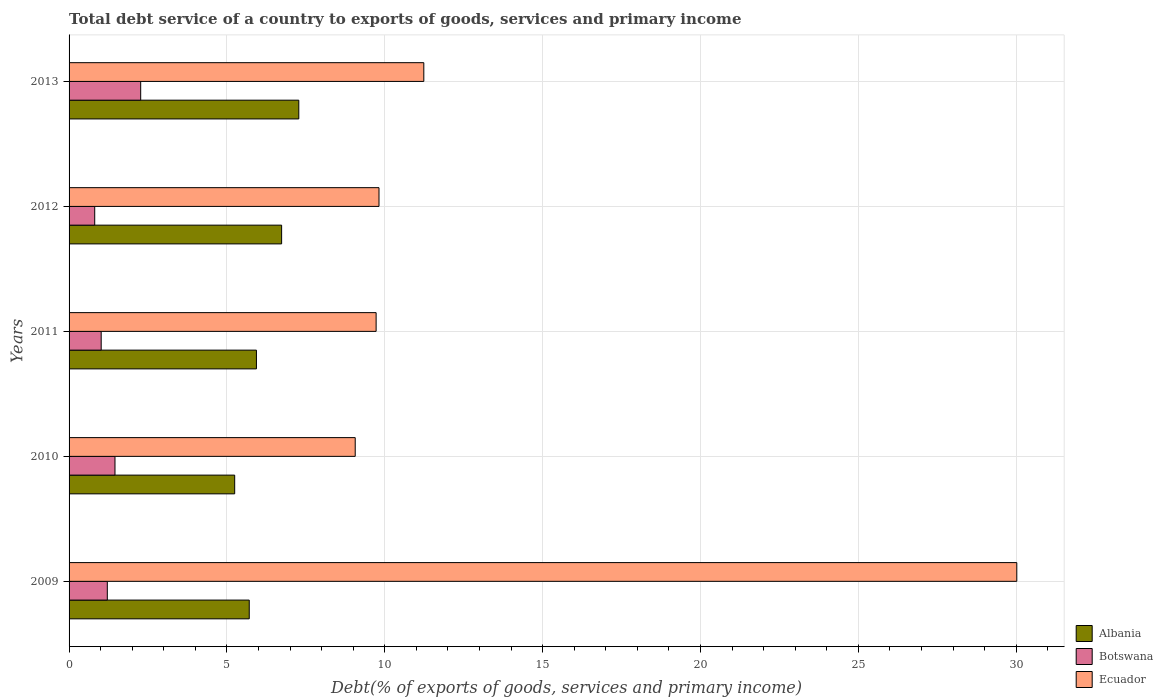How many different coloured bars are there?
Give a very brief answer. 3. How many groups of bars are there?
Your answer should be very brief. 5. How many bars are there on the 3rd tick from the bottom?
Your answer should be very brief. 3. What is the label of the 2nd group of bars from the top?
Your answer should be very brief. 2012. In how many cases, is the number of bars for a given year not equal to the number of legend labels?
Your response must be concise. 0. What is the total debt service in Albania in 2010?
Your answer should be compact. 5.25. Across all years, what is the maximum total debt service in Albania?
Offer a very short reply. 7.28. Across all years, what is the minimum total debt service in Botswana?
Your response must be concise. 0.81. In which year was the total debt service in Albania minimum?
Provide a short and direct response. 2010. What is the total total debt service in Ecuador in the graph?
Your answer should be very brief. 69.87. What is the difference between the total debt service in Botswana in 2012 and that in 2013?
Offer a very short reply. -1.46. What is the difference between the total debt service in Botswana in 2011 and the total debt service in Ecuador in 2012?
Offer a very short reply. -8.8. What is the average total debt service in Botswana per year?
Make the answer very short. 1.35. In the year 2010, what is the difference between the total debt service in Albania and total debt service in Ecuador?
Your answer should be very brief. -3.82. In how many years, is the total debt service in Ecuador greater than 13 %?
Offer a terse response. 1. What is the ratio of the total debt service in Botswana in 2011 to that in 2012?
Ensure brevity in your answer.  1.25. What is the difference between the highest and the second highest total debt service in Ecuador?
Offer a very short reply. 18.78. What is the difference between the highest and the lowest total debt service in Botswana?
Offer a very short reply. 1.46. Is the sum of the total debt service in Botswana in 2009 and 2010 greater than the maximum total debt service in Ecuador across all years?
Keep it short and to the point. No. What does the 3rd bar from the top in 2009 represents?
Offer a terse response. Albania. What does the 2nd bar from the bottom in 2009 represents?
Provide a short and direct response. Botswana. How many bars are there?
Give a very brief answer. 15. How many years are there in the graph?
Provide a short and direct response. 5. What is the difference between two consecutive major ticks on the X-axis?
Your answer should be compact. 5. Does the graph contain grids?
Offer a very short reply. Yes. What is the title of the graph?
Give a very brief answer. Total debt service of a country to exports of goods, services and primary income. Does "Iran" appear as one of the legend labels in the graph?
Offer a terse response. No. What is the label or title of the X-axis?
Make the answer very short. Debt(% of exports of goods, services and primary income). What is the label or title of the Y-axis?
Your answer should be very brief. Years. What is the Debt(% of exports of goods, services and primary income) of Albania in 2009?
Keep it short and to the point. 5.71. What is the Debt(% of exports of goods, services and primary income) in Botswana in 2009?
Provide a short and direct response. 1.21. What is the Debt(% of exports of goods, services and primary income) of Ecuador in 2009?
Keep it short and to the point. 30.02. What is the Debt(% of exports of goods, services and primary income) of Albania in 2010?
Your response must be concise. 5.25. What is the Debt(% of exports of goods, services and primary income) in Botswana in 2010?
Make the answer very short. 1.45. What is the Debt(% of exports of goods, services and primary income) in Ecuador in 2010?
Offer a very short reply. 9.06. What is the Debt(% of exports of goods, services and primary income) of Albania in 2011?
Ensure brevity in your answer.  5.94. What is the Debt(% of exports of goods, services and primary income) in Botswana in 2011?
Your response must be concise. 1.02. What is the Debt(% of exports of goods, services and primary income) of Ecuador in 2011?
Your response must be concise. 9.73. What is the Debt(% of exports of goods, services and primary income) in Albania in 2012?
Offer a very short reply. 6.73. What is the Debt(% of exports of goods, services and primary income) in Botswana in 2012?
Make the answer very short. 0.81. What is the Debt(% of exports of goods, services and primary income) of Ecuador in 2012?
Provide a succinct answer. 9.82. What is the Debt(% of exports of goods, services and primary income) in Albania in 2013?
Offer a terse response. 7.28. What is the Debt(% of exports of goods, services and primary income) of Botswana in 2013?
Your response must be concise. 2.27. What is the Debt(% of exports of goods, services and primary income) in Ecuador in 2013?
Make the answer very short. 11.24. Across all years, what is the maximum Debt(% of exports of goods, services and primary income) of Albania?
Make the answer very short. 7.28. Across all years, what is the maximum Debt(% of exports of goods, services and primary income) of Botswana?
Your answer should be very brief. 2.27. Across all years, what is the maximum Debt(% of exports of goods, services and primary income) in Ecuador?
Provide a short and direct response. 30.02. Across all years, what is the minimum Debt(% of exports of goods, services and primary income) in Albania?
Make the answer very short. 5.25. Across all years, what is the minimum Debt(% of exports of goods, services and primary income) in Botswana?
Provide a succinct answer. 0.81. Across all years, what is the minimum Debt(% of exports of goods, services and primary income) in Ecuador?
Ensure brevity in your answer.  9.06. What is the total Debt(% of exports of goods, services and primary income) of Albania in the graph?
Offer a very short reply. 30.9. What is the total Debt(% of exports of goods, services and primary income) in Botswana in the graph?
Your answer should be compact. 6.76. What is the total Debt(% of exports of goods, services and primary income) in Ecuador in the graph?
Make the answer very short. 69.87. What is the difference between the Debt(% of exports of goods, services and primary income) in Albania in 2009 and that in 2010?
Your answer should be compact. 0.46. What is the difference between the Debt(% of exports of goods, services and primary income) in Botswana in 2009 and that in 2010?
Keep it short and to the point. -0.24. What is the difference between the Debt(% of exports of goods, services and primary income) of Ecuador in 2009 and that in 2010?
Keep it short and to the point. 20.96. What is the difference between the Debt(% of exports of goods, services and primary income) of Albania in 2009 and that in 2011?
Provide a succinct answer. -0.23. What is the difference between the Debt(% of exports of goods, services and primary income) of Botswana in 2009 and that in 2011?
Your answer should be very brief. 0.19. What is the difference between the Debt(% of exports of goods, services and primary income) in Ecuador in 2009 and that in 2011?
Provide a succinct answer. 20.29. What is the difference between the Debt(% of exports of goods, services and primary income) in Albania in 2009 and that in 2012?
Make the answer very short. -1.03. What is the difference between the Debt(% of exports of goods, services and primary income) of Botswana in 2009 and that in 2012?
Ensure brevity in your answer.  0.4. What is the difference between the Debt(% of exports of goods, services and primary income) in Ecuador in 2009 and that in 2012?
Offer a terse response. 20.2. What is the difference between the Debt(% of exports of goods, services and primary income) in Albania in 2009 and that in 2013?
Offer a very short reply. -1.57. What is the difference between the Debt(% of exports of goods, services and primary income) of Botswana in 2009 and that in 2013?
Offer a very short reply. -1.06. What is the difference between the Debt(% of exports of goods, services and primary income) in Ecuador in 2009 and that in 2013?
Your answer should be compact. 18.78. What is the difference between the Debt(% of exports of goods, services and primary income) of Albania in 2010 and that in 2011?
Your answer should be very brief. -0.69. What is the difference between the Debt(% of exports of goods, services and primary income) in Botswana in 2010 and that in 2011?
Provide a short and direct response. 0.44. What is the difference between the Debt(% of exports of goods, services and primary income) in Ecuador in 2010 and that in 2011?
Your answer should be very brief. -0.66. What is the difference between the Debt(% of exports of goods, services and primary income) in Albania in 2010 and that in 2012?
Keep it short and to the point. -1.49. What is the difference between the Debt(% of exports of goods, services and primary income) in Botswana in 2010 and that in 2012?
Make the answer very short. 0.64. What is the difference between the Debt(% of exports of goods, services and primary income) in Ecuador in 2010 and that in 2012?
Keep it short and to the point. -0.75. What is the difference between the Debt(% of exports of goods, services and primary income) of Albania in 2010 and that in 2013?
Provide a short and direct response. -2.03. What is the difference between the Debt(% of exports of goods, services and primary income) in Botswana in 2010 and that in 2013?
Offer a terse response. -0.81. What is the difference between the Debt(% of exports of goods, services and primary income) of Ecuador in 2010 and that in 2013?
Your response must be concise. -2.17. What is the difference between the Debt(% of exports of goods, services and primary income) of Albania in 2011 and that in 2012?
Offer a terse response. -0.8. What is the difference between the Debt(% of exports of goods, services and primary income) in Botswana in 2011 and that in 2012?
Offer a very short reply. 0.2. What is the difference between the Debt(% of exports of goods, services and primary income) in Ecuador in 2011 and that in 2012?
Give a very brief answer. -0.09. What is the difference between the Debt(% of exports of goods, services and primary income) in Albania in 2011 and that in 2013?
Offer a very short reply. -1.34. What is the difference between the Debt(% of exports of goods, services and primary income) in Botswana in 2011 and that in 2013?
Offer a terse response. -1.25. What is the difference between the Debt(% of exports of goods, services and primary income) of Ecuador in 2011 and that in 2013?
Offer a very short reply. -1.51. What is the difference between the Debt(% of exports of goods, services and primary income) in Albania in 2012 and that in 2013?
Your response must be concise. -0.54. What is the difference between the Debt(% of exports of goods, services and primary income) of Botswana in 2012 and that in 2013?
Provide a succinct answer. -1.46. What is the difference between the Debt(% of exports of goods, services and primary income) of Ecuador in 2012 and that in 2013?
Offer a terse response. -1.42. What is the difference between the Debt(% of exports of goods, services and primary income) of Albania in 2009 and the Debt(% of exports of goods, services and primary income) of Botswana in 2010?
Your answer should be very brief. 4.25. What is the difference between the Debt(% of exports of goods, services and primary income) in Albania in 2009 and the Debt(% of exports of goods, services and primary income) in Ecuador in 2010?
Your answer should be very brief. -3.36. What is the difference between the Debt(% of exports of goods, services and primary income) in Botswana in 2009 and the Debt(% of exports of goods, services and primary income) in Ecuador in 2010?
Provide a succinct answer. -7.85. What is the difference between the Debt(% of exports of goods, services and primary income) of Albania in 2009 and the Debt(% of exports of goods, services and primary income) of Botswana in 2011?
Your response must be concise. 4.69. What is the difference between the Debt(% of exports of goods, services and primary income) of Albania in 2009 and the Debt(% of exports of goods, services and primary income) of Ecuador in 2011?
Provide a succinct answer. -4.02. What is the difference between the Debt(% of exports of goods, services and primary income) in Botswana in 2009 and the Debt(% of exports of goods, services and primary income) in Ecuador in 2011?
Make the answer very short. -8.52. What is the difference between the Debt(% of exports of goods, services and primary income) of Albania in 2009 and the Debt(% of exports of goods, services and primary income) of Botswana in 2012?
Offer a very short reply. 4.89. What is the difference between the Debt(% of exports of goods, services and primary income) in Albania in 2009 and the Debt(% of exports of goods, services and primary income) in Ecuador in 2012?
Offer a very short reply. -4.11. What is the difference between the Debt(% of exports of goods, services and primary income) in Botswana in 2009 and the Debt(% of exports of goods, services and primary income) in Ecuador in 2012?
Provide a succinct answer. -8.61. What is the difference between the Debt(% of exports of goods, services and primary income) in Albania in 2009 and the Debt(% of exports of goods, services and primary income) in Botswana in 2013?
Offer a very short reply. 3.44. What is the difference between the Debt(% of exports of goods, services and primary income) of Albania in 2009 and the Debt(% of exports of goods, services and primary income) of Ecuador in 2013?
Your answer should be very brief. -5.53. What is the difference between the Debt(% of exports of goods, services and primary income) in Botswana in 2009 and the Debt(% of exports of goods, services and primary income) in Ecuador in 2013?
Make the answer very short. -10.03. What is the difference between the Debt(% of exports of goods, services and primary income) of Albania in 2010 and the Debt(% of exports of goods, services and primary income) of Botswana in 2011?
Give a very brief answer. 4.23. What is the difference between the Debt(% of exports of goods, services and primary income) in Albania in 2010 and the Debt(% of exports of goods, services and primary income) in Ecuador in 2011?
Give a very brief answer. -4.48. What is the difference between the Debt(% of exports of goods, services and primary income) in Botswana in 2010 and the Debt(% of exports of goods, services and primary income) in Ecuador in 2011?
Keep it short and to the point. -8.27. What is the difference between the Debt(% of exports of goods, services and primary income) in Albania in 2010 and the Debt(% of exports of goods, services and primary income) in Botswana in 2012?
Provide a succinct answer. 4.43. What is the difference between the Debt(% of exports of goods, services and primary income) in Albania in 2010 and the Debt(% of exports of goods, services and primary income) in Ecuador in 2012?
Keep it short and to the point. -4.57. What is the difference between the Debt(% of exports of goods, services and primary income) of Botswana in 2010 and the Debt(% of exports of goods, services and primary income) of Ecuador in 2012?
Your answer should be compact. -8.36. What is the difference between the Debt(% of exports of goods, services and primary income) in Albania in 2010 and the Debt(% of exports of goods, services and primary income) in Botswana in 2013?
Your answer should be very brief. 2.98. What is the difference between the Debt(% of exports of goods, services and primary income) of Albania in 2010 and the Debt(% of exports of goods, services and primary income) of Ecuador in 2013?
Offer a terse response. -5.99. What is the difference between the Debt(% of exports of goods, services and primary income) in Botswana in 2010 and the Debt(% of exports of goods, services and primary income) in Ecuador in 2013?
Your answer should be compact. -9.78. What is the difference between the Debt(% of exports of goods, services and primary income) in Albania in 2011 and the Debt(% of exports of goods, services and primary income) in Botswana in 2012?
Ensure brevity in your answer.  5.12. What is the difference between the Debt(% of exports of goods, services and primary income) of Albania in 2011 and the Debt(% of exports of goods, services and primary income) of Ecuador in 2012?
Offer a very short reply. -3.88. What is the difference between the Debt(% of exports of goods, services and primary income) of Botswana in 2011 and the Debt(% of exports of goods, services and primary income) of Ecuador in 2012?
Offer a terse response. -8.8. What is the difference between the Debt(% of exports of goods, services and primary income) of Albania in 2011 and the Debt(% of exports of goods, services and primary income) of Botswana in 2013?
Provide a succinct answer. 3.67. What is the difference between the Debt(% of exports of goods, services and primary income) of Albania in 2011 and the Debt(% of exports of goods, services and primary income) of Ecuador in 2013?
Offer a very short reply. -5.3. What is the difference between the Debt(% of exports of goods, services and primary income) of Botswana in 2011 and the Debt(% of exports of goods, services and primary income) of Ecuador in 2013?
Provide a succinct answer. -10.22. What is the difference between the Debt(% of exports of goods, services and primary income) in Albania in 2012 and the Debt(% of exports of goods, services and primary income) in Botswana in 2013?
Provide a short and direct response. 4.46. What is the difference between the Debt(% of exports of goods, services and primary income) of Albania in 2012 and the Debt(% of exports of goods, services and primary income) of Ecuador in 2013?
Ensure brevity in your answer.  -4.5. What is the difference between the Debt(% of exports of goods, services and primary income) of Botswana in 2012 and the Debt(% of exports of goods, services and primary income) of Ecuador in 2013?
Provide a short and direct response. -10.42. What is the average Debt(% of exports of goods, services and primary income) in Albania per year?
Provide a short and direct response. 6.18. What is the average Debt(% of exports of goods, services and primary income) of Botswana per year?
Ensure brevity in your answer.  1.35. What is the average Debt(% of exports of goods, services and primary income) in Ecuador per year?
Offer a very short reply. 13.97. In the year 2009, what is the difference between the Debt(% of exports of goods, services and primary income) in Albania and Debt(% of exports of goods, services and primary income) in Botswana?
Ensure brevity in your answer.  4.5. In the year 2009, what is the difference between the Debt(% of exports of goods, services and primary income) of Albania and Debt(% of exports of goods, services and primary income) of Ecuador?
Offer a very short reply. -24.31. In the year 2009, what is the difference between the Debt(% of exports of goods, services and primary income) in Botswana and Debt(% of exports of goods, services and primary income) in Ecuador?
Your answer should be very brief. -28.81. In the year 2010, what is the difference between the Debt(% of exports of goods, services and primary income) in Albania and Debt(% of exports of goods, services and primary income) in Botswana?
Your answer should be compact. 3.79. In the year 2010, what is the difference between the Debt(% of exports of goods, services and primary income) of Albania and Debt(% of exports of goods, services and primary income) of Ecuador?
Provide a short and direct response. -3.82. In the year 2010, what is the difference between the Debt(% of exports of goods, services and primary income) of Botswana and Debt(% of exports of goods, services and primary income) of Ecuador?
Offer a very short reply. -7.61. In the year 2011, what is the difference between the Debt(% of exports of goods, services and primary income) in Albania and Debt(% of exports of goods, services and primary income) in Botswana?
Offer a very short reply. 4.92. In the year 2011, what is the difference between the Debt(% of exports of goods, services and primary income) of Albania and Debt(% of exports of goods, services and primary income) of Ecuador?
Keep it short and to the point. -3.79. In the year 2011, what is the difference between the Debt(% of exports of goods, services and primary income) of Botswana and Debt(% of exports of goods, services and primary income) of Ecuador?
Your answer should be compact. -8.71. In the year 2012, what is the difference between the Debt(% of exports of goods, services and primary income) in Albania and Debt(% of exports of goods, services and primary income) in Botswana?
Your response must be concise. 5.92. In the year 2012, what is the difference between the Debt(% of exports of goods, services and primary income) in Albania and Debt(% of exports of goods, services and primary income) in Ecuador?
Your answer should be compact. -3.08. In the year 2012, what is the difference between the Debt(% of exports of goods, services and primary income) in Botswana and Debt(% of exports of goods, services and primary income) in Ecuador?
Your response must be concise. -9. In the year 2013, what is the difference between the Debt(% of exports of goods, services and primary income) of Albania and Debt(% of exports of goods, services and primary income) of Botswana?
Your answer should be very brief. 5.01. In the year 2013, what is the difference between the Debt(% of exports of goods, services and primary income) of Albania and Debt(% of exports of goods, services and primary income) of Ecuador?
Keep it short and to the point. -3.96. In the year 2013, what is the difference between the Debt(% of exports of goods, services and primary income) of Botswana and Debt(% of exports of goods, services and primary income) of Ecuador?
Provide a short and direct response. -8.97. What is the ratio of the Debt(% of exports of goods, services and primary income) of Albania in 2009 to that in 2010?
Make the answer very short. 1.09. What is the ratio of the Debt(% of exports of goods, services and primary income) in Botswana in 2009 to that in 2010?
Offer a very short reply. 0.83. What is the ratio of the Debt(% of exports of goods, services and primary income) in Ecuador in 2009 to that in 2010?
Your answer should be compact. 3.31. What is the ratio of the Debt(% of exports of goods, services and primary income) of Albania in 2009 to that in 2011?
Provide a succinct answer. 0.96. What is the ratio of the Debt(% of exports of goods, services and primary income) of Botswana in 2009 to that in 2011?
Provide a succinct answer. 1.19. What is the ratio of the Debt(% of exports of goods, services and primary income) of Ecuador in 2009 to that in 2011?
Offer a terse response. 3.09. What is the ratio of the Debt(% of exports of goods, services and primary income) of Albania in 2009 to that in 2012?
Offer a very short reply. 0.85. What is the ratio of the Debt(% of exports of goods, services and primary income) in Botswana in 2009 to that in 2012?
Provide a succinct answer. 1.49. What is the ratio of the Debt(% of exports of goods, services and primary income) of Ecuador in 2009 to that in 2012?
Your answer should be very brief. 3.06. What is the ratio of the Debt(% of exports of goods, services and primary income) in Albania in 2009 to that in 2013?
Your answer should be very brief. 0.78. What is the ratio of the Debt(% of exports of goods, services and primary income) in Botswana in 2009 to that in 2013?
Your answer should be very brief. 0.53. What is the ratio of the Debt(% of exports of goods, services and primary income) of Ecuador in 2009 to that in 2013?
Offer a very short reply. 2.67. What is the ratio of the Debt(% of exports of goods, services and primary income) in Albania in 2010 to that in 2011?
Provide a succinct answer. 0.88. What is the ratio of the Debt(% of exports of goods, services and primary income) of Botswana in 2010 to that in 2011?
Give a very brief answer. 1.43. What is the ratio of the Debt(% of exports of goods, services and primary income) in Ecuador in 2010 to that in 2011?
Your answer should be compact. 0.93. What is the ratio of the Debt(% of exports of goods, services and primary income) in Albania in 2010 to that in 2012?
Your response must be concise. 0.78. What is the ratio of the Debt(% of exports of goods, services and primary income) in Botswana in 2010 to that in 2012?
Your answer should be compact. 1.79. What is the ratio of the Debt(% of exports of goods, services and primary income) in Ecuador in 2010 to that in 2012?
Keep it short and to the point. 0.92. What is the ratio of the Debt(% of exports of goods, services and primary income) in Albania in 2010 to that in 2013?
Ensure brevity in your answer.  0.72. What is the ratio of the Debt(% of exports of goods, services and primary income) of Botswana in 2010 to that in 2013?
Keep it short and to the point. 0.64. What is the ratio of the Debt(% of exports of goods, services and primary income) of Ecuador in 2010 to that in 2013?
Provide a short and direct response. 0.81. What is the ratio of the Debt(% of exports of goods, services and primary income) in Albania in 2011 to that in 2012?
Provide a succinct answer. 0.88. What is the ratio of the Debt(% of exports of goods, services and primary income) of Botswana in 2011 to that in 2012?
Your answer should be compact. 1.25. What is the ratio of the Debt(% of exports of goods, services and primary income) of Albania in 2011 to that in 2013?
Keep it short and to the point. 0.82. What is the ratio of the Debt(% of exports of goods, services and primary income) of Botswana in 2011 to that in 2013?
Provide a short and direct response. 0.45. What is the ratio of the Debt(% of exports of goods, services and primary income) in Ecuador in 2011 to that in 2013?
Provide a succinct answer. 0.87. What is the ratio of the Debt(% of exports of goods, services and primary income) of Albania in 2012 to that in 2013?
Make the answer very short. 0.93. What is the ratio of the Debt(% of exports of goods, services and primary income) in Botswana in 2012 to that in 2013?
Your response must be concise. 0.36. What is the ratio of the Debt(% of exports of goods, services and primary income) of Ecuador in 2012 to that in 2013?
Provide a succinct answer. 0.87. What is the difference between the highest and the second highest Debt(% of exports of goods, services and primary income) of Albania?
Your answer should be compact. 0.54. What is the difference between the highest and the second highest Debt(% of exports of goods, services and primary income) in Botswana?
Offer a very short reply. 0.81. What is the difference between the highest and the second highest Debt(% of exports of goods, services and primary income) in Ecuador?
Ensure brevity in your answer.  18.78. What is the difference between the highest and the lowest Debt(% of exports of goods, services and primary income) of Albania?
Your response must be concise. 2.03. What is the difference between the highest and the lowest Debt(% of exports of goods, services and primary income) in Botswana?
Make the answer very short. 1.46. What is the difference between the highest and the lowest Debt(% of exports of goods, services and primary income) of Ecuador?
Provide a short and direct response. 20.96. 